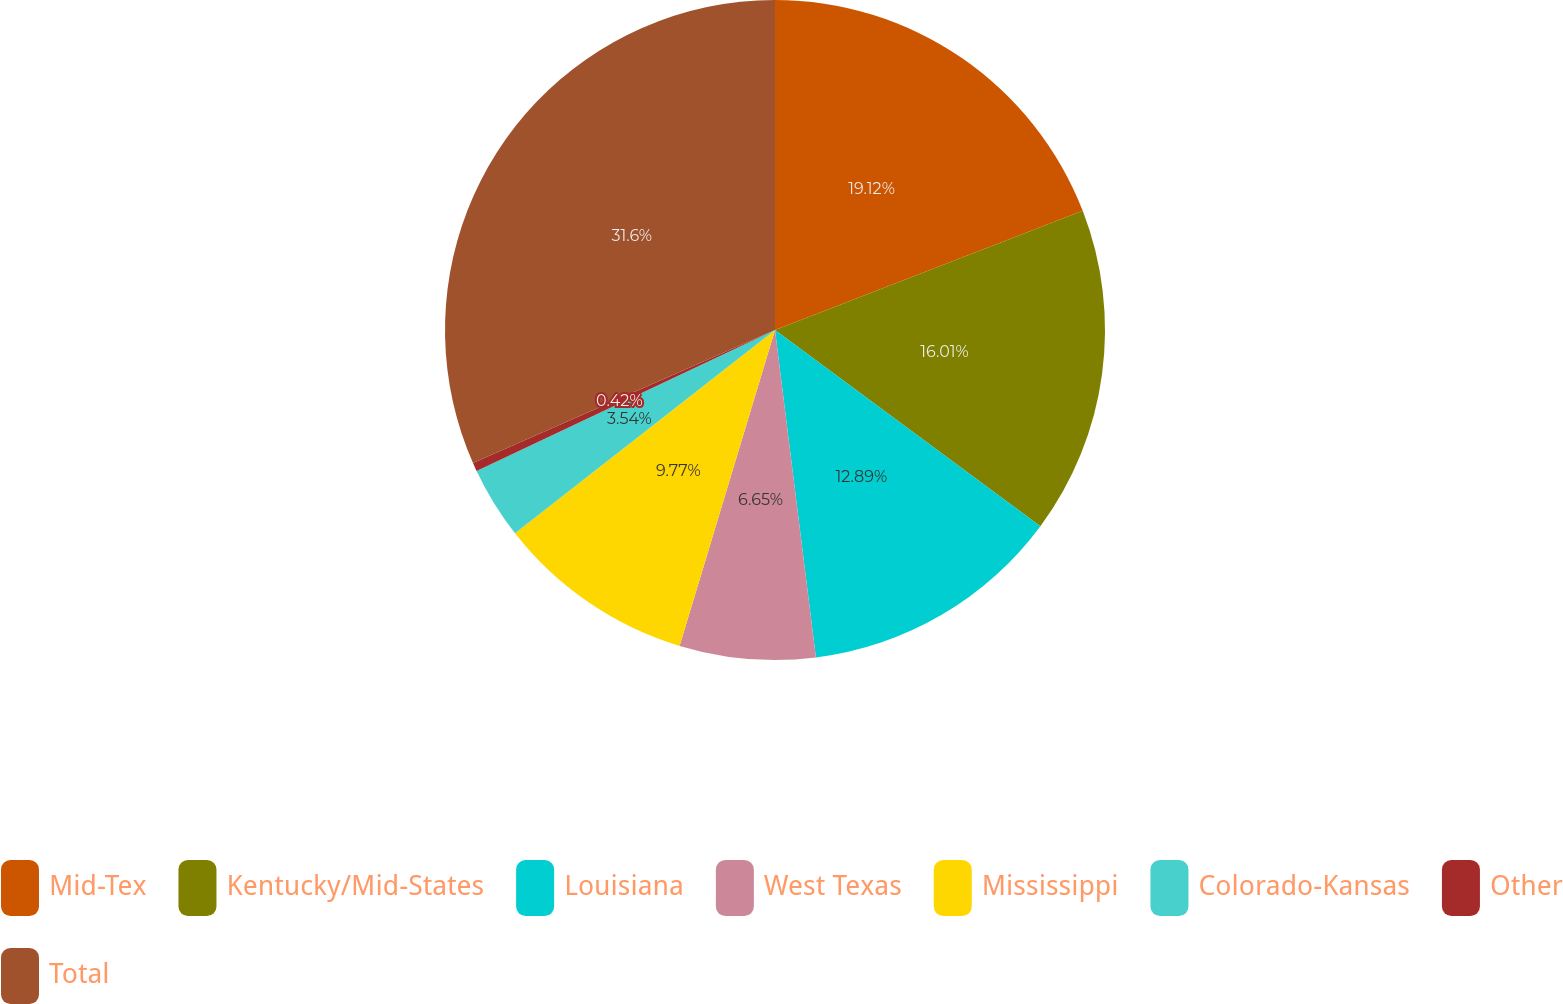Convert chart. <chart><loc_0><loc_0><loc_500><loc_500><pie_chart><fcel>Mid-Tex<fcel>Kentucky/Mid-States<fcel>Louisiana<fcel>West Texas<fcel>Mississippi<fcel>Colorado-Kansas<fcel>Other<fcel>Total<nl><fcel>19.12%<fcel>16.01%<fcel>12.89%<fcel>6.65%<fcel>9.77%<fcel>3.54%<fcel>0.42%<fcel>31.6%<nl></chart> 